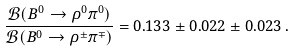<formula> <loc_0><loc_0><loc_500><loc_500>\frac { \mathcal { B } ( B ^ { 0 } \rightarrow \rho ^ { 0 } \pi ^ { 0 } ) } { \mathcal { B } ( B ^ { 0 } \rightarrow \rho ^ { \pm } \pi ^ { \mp } ) } = 0 . 1 3 3 \pm 0 . 0 2 2 \pm 0 . 0 2 3 \, .</formula> 